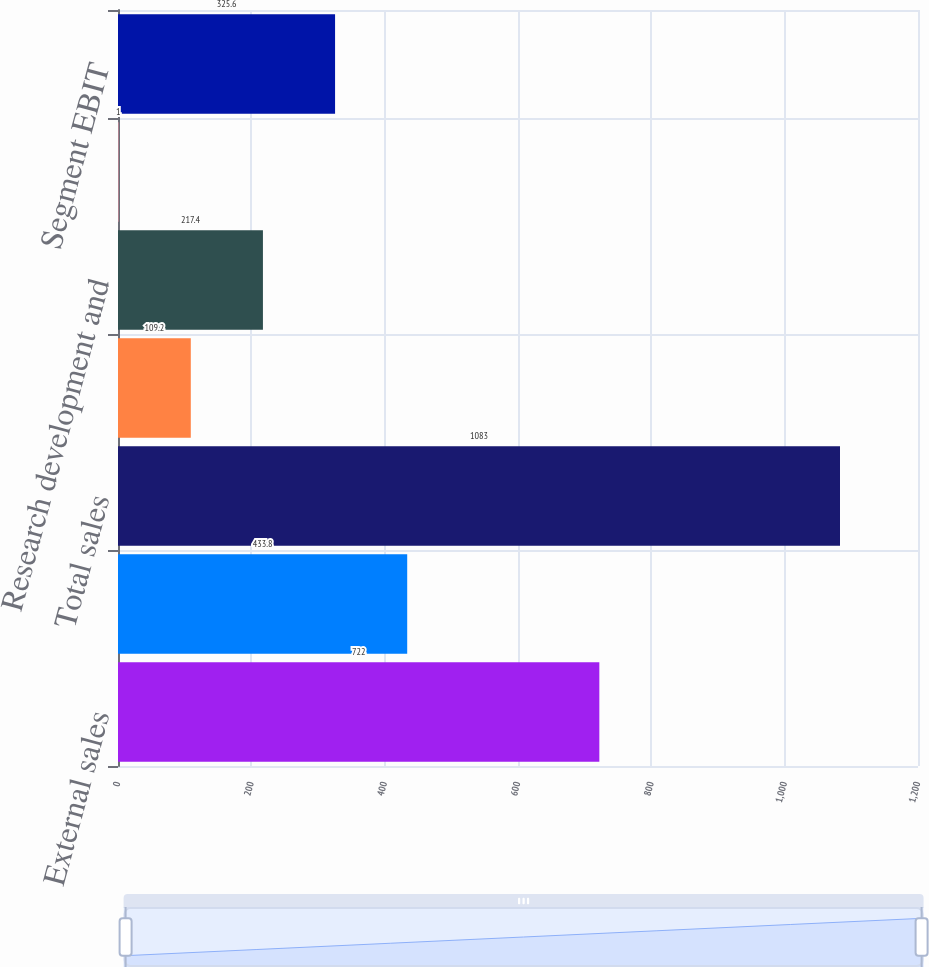Convert chart. <chart><loc_0><loc_0><loc_500><loc_500><bar_chart><fcel>External sales<fcel>Intersegment sales<fcel>Total sales<fcel>Depreciation and amortization<fcel>Research development and<fcel>Equity royalty and interest<fcel>Segment EBIT<nl><fcel>722<fcel>433.8<fcel>1083<fcel>109.2<fcel>217.4<fcel>1<fcel>325.6<nl></chart> 